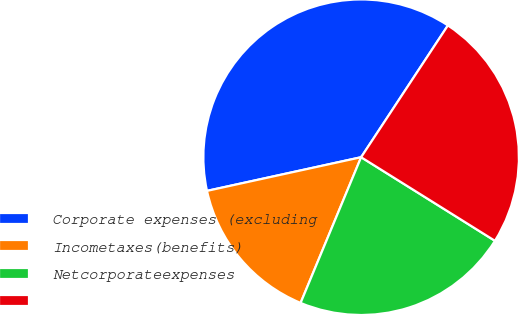<chart> <loc_0><loc_0><loc_500><loc_500><pie_chart><fcel>Corporate expenses (excluding<fcel>Incometaxes(benefits)<fcel>Netcorporateexpenses<fcel>Unnamed: 3<nl><fcel>37.69%<fcel>15.31%<fcel>22.38%<fcel>24.62%<nl></chart> 